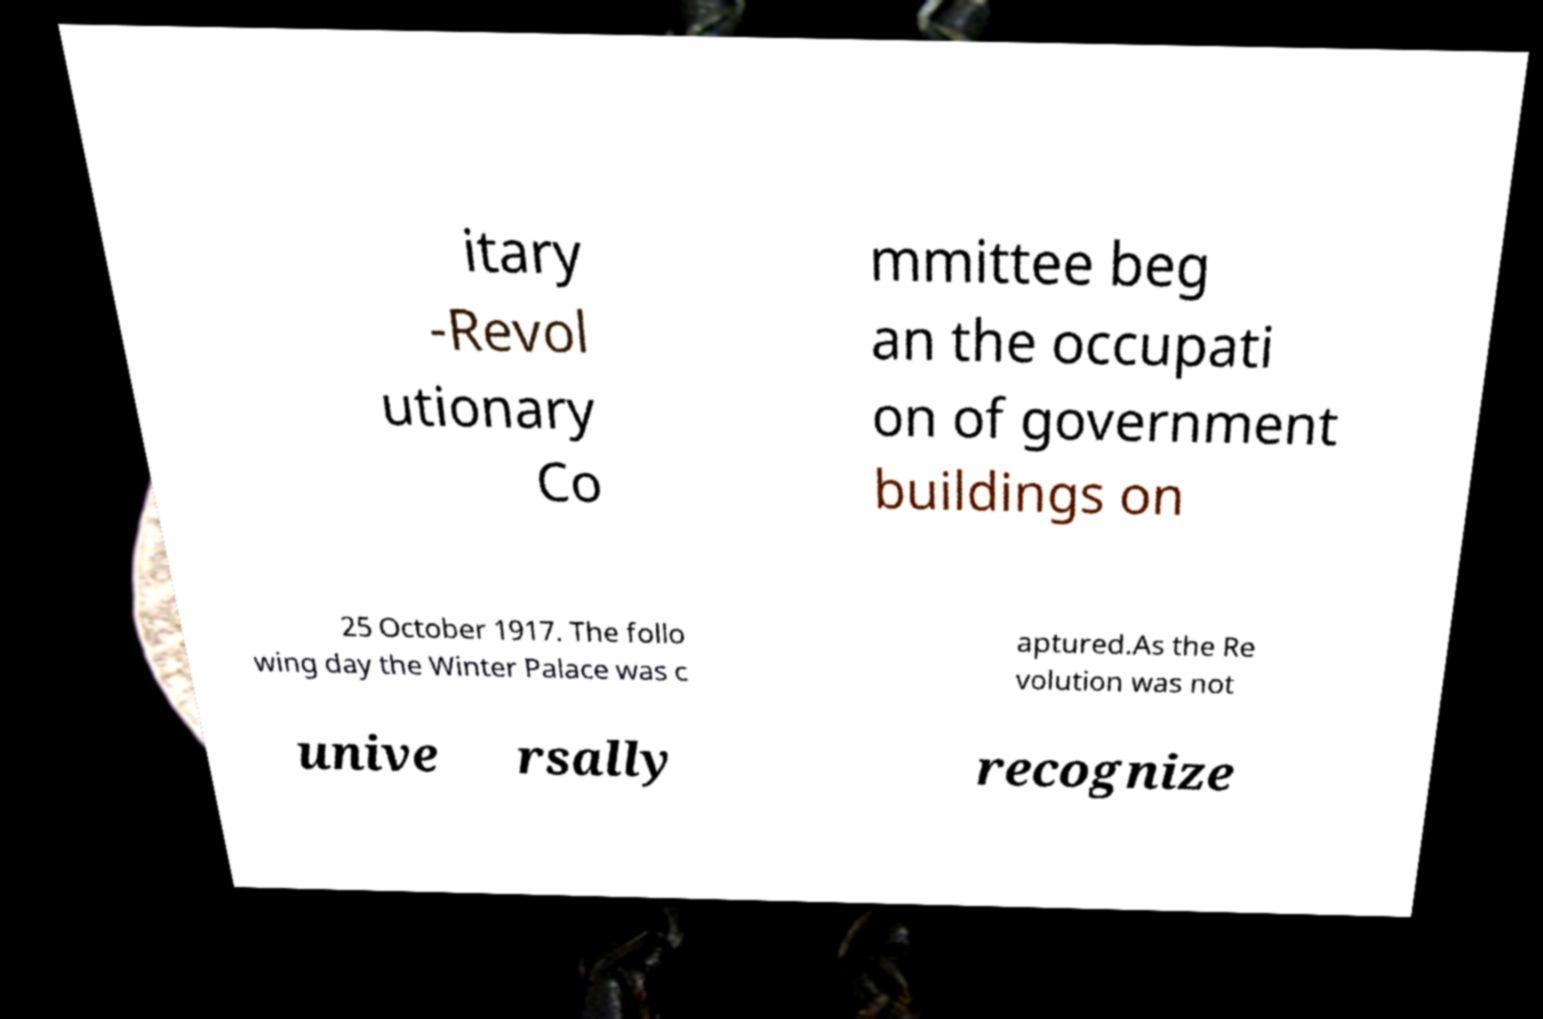There's text embedded in this image that I need extracted. Can you transcribe it verbatim? itary -Revol utionary Co mmittee beg an the occupati on of government buildings on 25 October 1917. The follo wing day the Winter Palace was c aptured.As the Re volution was not unive rsally recognize 